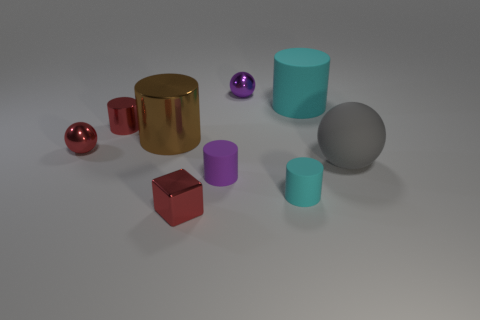There is a big gray thing that is the same shape as the small purple metal object; what material is it?
Your answer should be compact. Rubber. Is there a big purple matte block?
Keep it short and to the point. No. What shape is the purple object that is the same material as the brown object?
Offer a very short reply. Sphere. There is a purple object that is in front of the large brown object; what is its material?
Your response must be concise. Rubber. There is a small cylinder behind the gray ball; does it have the same color as the block?
Give a very brief answer. Yes. There is a metallic sphere that is right of the tiny shiny sphere to the left of the brown metallic object; what size is it?
Keep it short and to the point. Small. Is the number of spheres in front of the large brown cylinder greater than the number of big gray shiny spheres?
Keep it short and to the point. Yes. There is a metallic object that is to the left of the red shiny cylinder; is it the same size as the purple cylinder?
Your response must be concise. Yes. What is the color of the sphere that is both to the left of the big gray rubber ball and in front of the tiny metal cylinder?
Your answer should be very brief. Red. What shape is the purple metal thing that is the same size as the red shiny sphere?
Provide a short and direct response. Sphere. 